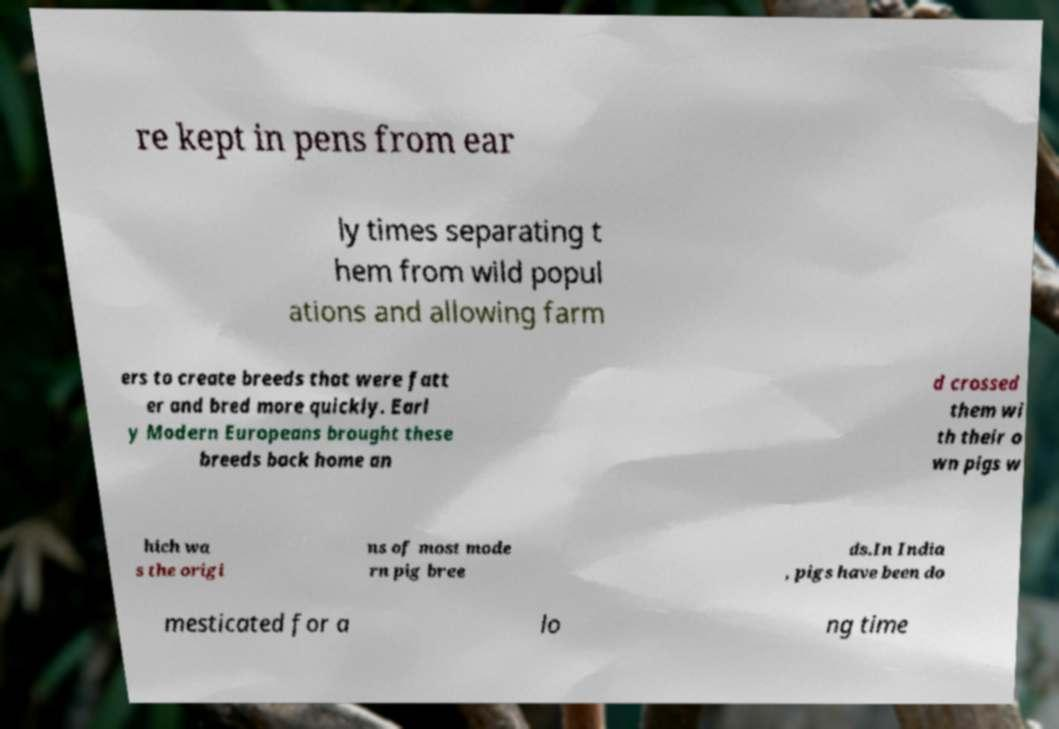Could you extract and type out the text from this image? re kept in pens from ear ly times separating t hem from wild popul ations and allowing farm ers to create breeds that were fatt er and bred more quickly. Earl y Modern Europeans brought these breeds back home an d crossed them wi th their o wn pigs w hich wa s the origi ns of most mode rn pig bree ds.In India , pigs have been do mesticated for a lo ng time 